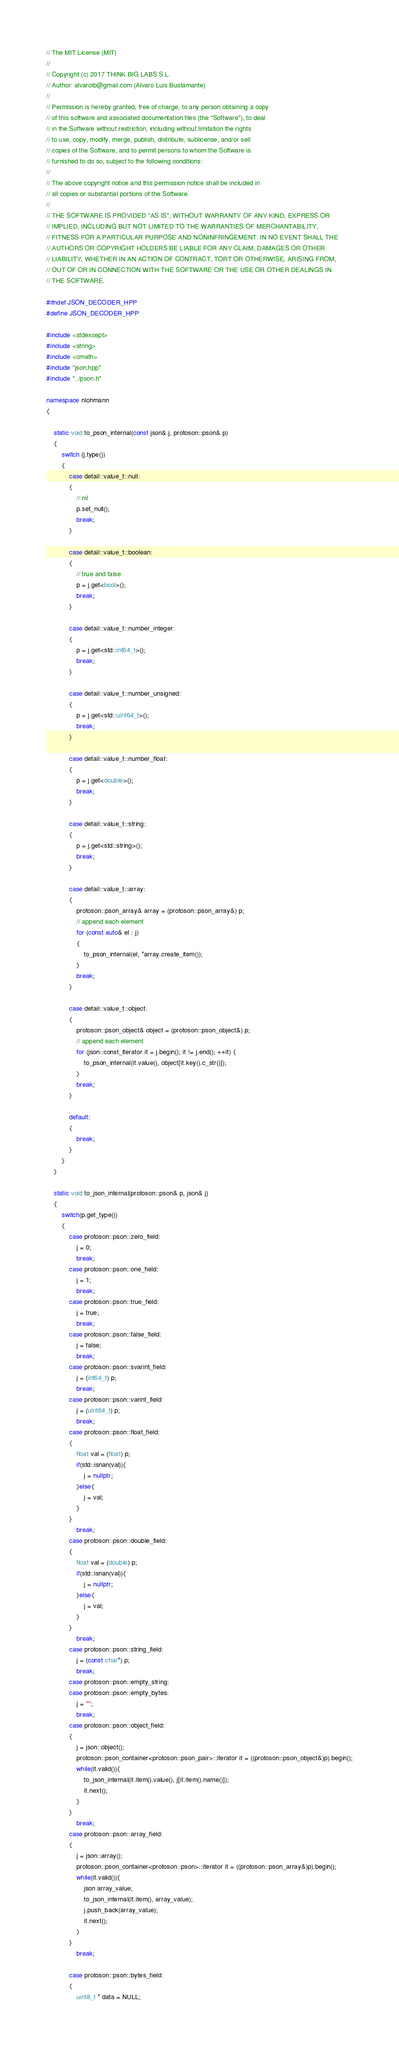Convert code to text. <code><loc_0><loc_0><loc_500><loc_500><_C++_>// The MIT License (MIT)
//
// Copyright (c) 2017 THINK BIG LABS S.L.
// Author: alvarolb@gmail.com (Alvaro Luis Bustamante)
//
// Permission is hereby granted, free of charge, to any person obtaining a copy
// of this software and associated documentation files (the "Software"), to deal
// in the Software without restriction, including without limitation the rights
// to use, copy, modify, merge, publish, distribute, sublicense, and/or sell
// copies of the Software, and to permit persons to whom the Software is
// furnished to do so, subject to the following conditions:
//
// The above copyright notice and this permission notice shall be included in
// all copies or substantial portions of the Software.
//
// THE SOFTWARE IS PROVIDED "AS IS", WITHOUT WARRANTY OF ANY KIND, EXPRESS OR
// IMPLIED, INCLUDING BUT NOT LIMITED TO THE WARRANTIES OF MERCHANTABILITY,
// FITNESS FOR A PARTICULAR PURPOSE AND NONINFRINGEMENT. IN NO EVENT SHALL THE
// AUTHORS OR COPYRIGHT HOLDERS BE LIABLE FOR ANY CLAIM, DAMAGES OR OTHER
// LIABILITY, WHETHER IN AN ACTION OF CONTRACT, TORT OR OTHERWISE, ARISING FROM,
// OUT OF OR IN CONNECTION WITH THE SOFTWARE OR THE USE OR OTHER DEALINGS IN
// THE SOFTWARE.

#ifndef JSON_DECODER_HPP
#define JSON_DECODER_HPP

#include <stdexcept>
#include <string>
#include <cmath>
#include "json.hpp"
#include "../pson.h"

namespace nlohmann
{

    static void to_pson_internal(const json& j, protoson::pson& p)
    {
        switch (j.type())
        {
            case detail::value_t::null:
            {
                // nil
                p.set_null();
                break;
            }

            case detail::value_t::boolean:
            {
                // true and false
                p = j.get<bool>();
                break;
            }

            case detail::value_t::number_integer:
            {
                p = j.get<std::int64_t>();
                break;
            }

            case detail::value_t::number_unsigned:
            {
                p = j.get<std::uint64_t>();
                break;
            }

            case detail::value_t::number_float:
            {
                p = j.get<double>();
                break;
            }

            case detail::value_t::string:
            {
                p = j.get<std::string>();
                break;
            }

            case detail::value_t::array:
            {
                protoson::pson_array& array = (protoson::pson_array&) p;
                // append each element
                for (const auto& el : j)
                {
                    to_pson_internal(el, *array.create_item());
                }
                break;
            }

            case detail::value_t::object:
            {
                protoson::pson_object& object = (protoson::pson_object&) p;
                // append each element
                for (json::const_iterator it = j.begin(); it != j.end(); ++it) {
                    to_pson_internal(it.value(), object[it.key().c_str()]);
                }
                break;
            }

            default:
            {
                break;
            }
        }
    }

    static void to_json_internal(protoson::pson& p, json& j)
    {
        switch(p.get_type())
        {
            case protoson::pson::zero_field:
                j = 0;
                break;
            case protoson::pson::one_field:
                j = 1;
                break;
            case protoson::pson::true_field:
                j = true;
                break;
            case protoson::pson::false_field:
                j = false;
                break;
            case protoson::pson::svarint_field:
                j = (int64_t) p;
                break;
            case protoson::pson::varint_field:
                j = (uint64_t) p;
                break;
            case protoson::pson::float_field:
            {
                float val = (float) p;
                if(std::isnan(val)){
                    j = nullptr;
                }else{
                    j = val;
                }
            }
                break;
            case protoson::pson::double_field:
            {
                float val = (double) p;
                if(std::isnan(val)){
                    j = nullptr;
                }else{
                    j = val;
                }
            }
                break;
            case protoson::pson::string_field:
                j = (const char*) p;
                break;
            case protoson::pson::empty_string:
            case protoson::pson::empty_bytes:
                j = "";
                break;
            case protoson::pson::object_field:
            {
                j = json::object();
                protoson::pson_container<protoson::pson_pair>::iterator it = ((protoson::pson_object&)p).begin();
                while(it.valid()){
                    to_json_internal(it.item().value(), j[it.item().name()]);
                    it.next();
                }
            }
                break;
            case protoson::pson::array_field:
            {
                j = json::array();
                protoson::pson_container<protoson::pson>::iterator it = ((protoson::pson_array&)p).begin();
                while(it.valid()){
                    json array_value;
                    to_json_internal(it.item(), array_value);
                    j.push_back(array_value);
                    it.next();
                }
            }
                break;

            case protoson::pson::bytes_field:
            {
                uint8_t * data = NULL;</code> 